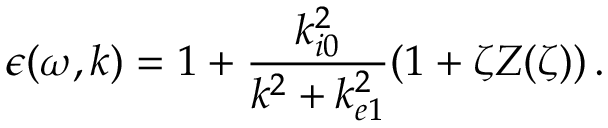Convert formula to latex. <formula><loc_0><loc_0><loc_500><loc_500>\epsilon ( \omega , k ) = 1 + \frac { k _ { i 0 } ^ { 2 } } { k ^ { 2 } + k _ { e 1 } ^ { 2 } } ( 1 + \zeta Z ( \zeta ) ) \, .</formula> 